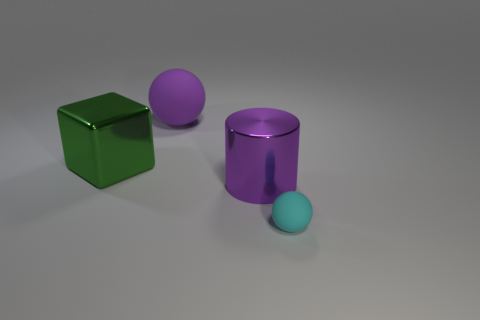Add 3 large blue shiny cubes. How many objects exist? 7 Subtract all cylinders. How many objects are left? 3 Subtract 0 cyan cubes. How many objects are left? 4 Subtract all yellow shiny blocks. Subtract all green metal objects. How many objects are left? 3 Add 2 tiny matte things. How many tiny matte things are left? 3 Add 3 red cylinders. How many red cylinders exist? 3 